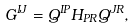Convert formula to latex. <formula><loc_0><loc_0><loc_500><loc_500>G ^ { I J } = Q ^ { I P } H _ { P R } Q ^ { J R } ,</formula> 